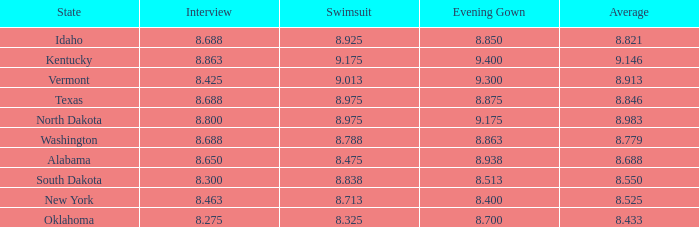Who obtained the minimum interview score from south dakota with an evening dress below None. Give me the full table as a dictionary. {'header': ['State', 'Interview', 'Swimsuit', 'Evening Gown', 'Average'], 'rows': [['Idaho', '8.688', '8.925', '8.850', '8.821'], ['Kentucky', '8.863', '9.175', '9.400', '9.146'], ['Vermont', '8.425', '9.013', '9.300', '8.913'], ['Texas', '8.688', '8.975', '8.875', '8.846'], ['North Dakota', '8.800', '8.975', '9.175', '8.983'], ['Washington', '8.688', '8.788', '8.863', '8.779'], ['Alabama', '8.650', '8.475', '8.938', '8.688'], ['South Dakota', '8.300', '8.838', '8.513', '8.550'], ['New York', '8.463', '8.713', '8.400', '8.525'], ['Oklahoma', '8.275', '8.325', '8.700', '8.433']]} 